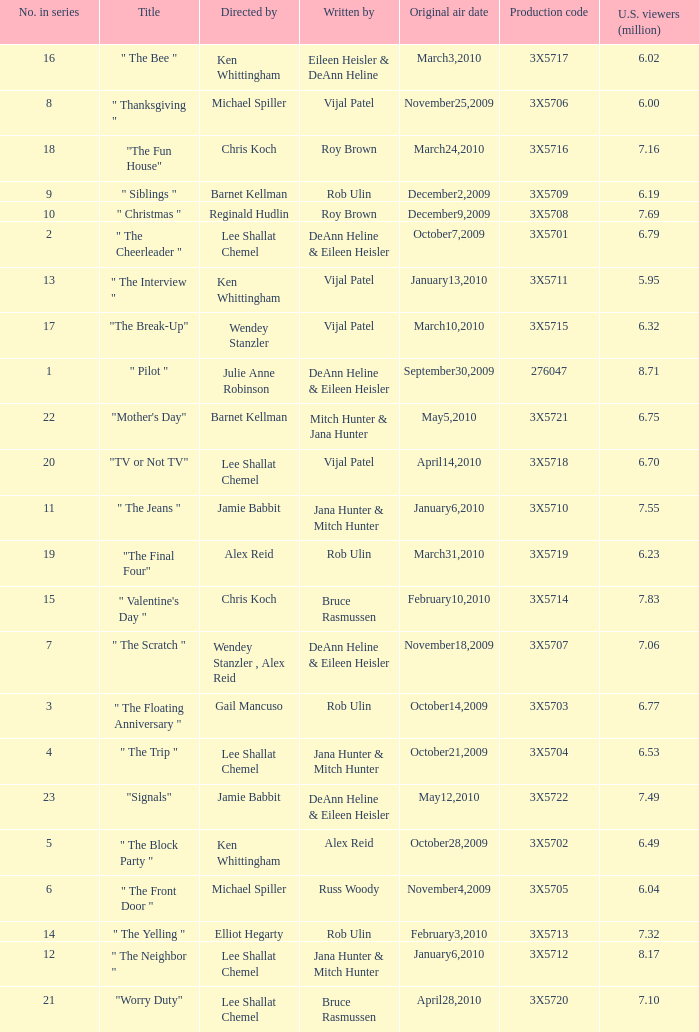What is the title of the episode Alex Reid directed? "The Final Four". 